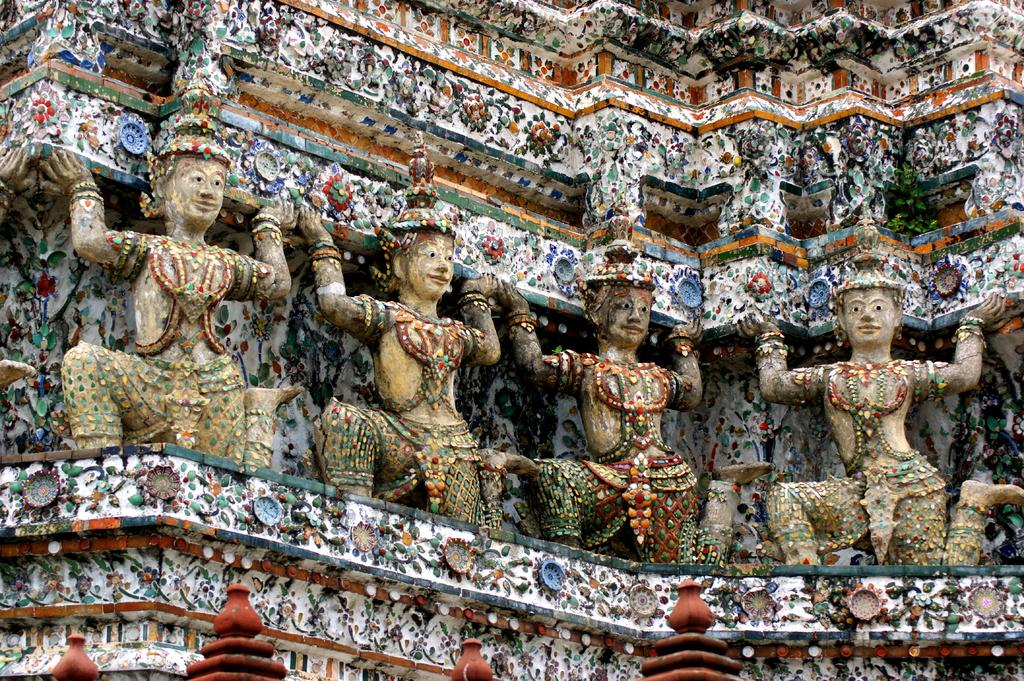What is present in the image? There is a wall in the image. Can you describe the wall? The wall has a design. What can be seen on the wall? There are sculptures on the wall. What type of fiction is being read by the sculptures on the wall? There is no indication in the image that the sculptures are reading any fiction, as sculptures are not capable of reading. 